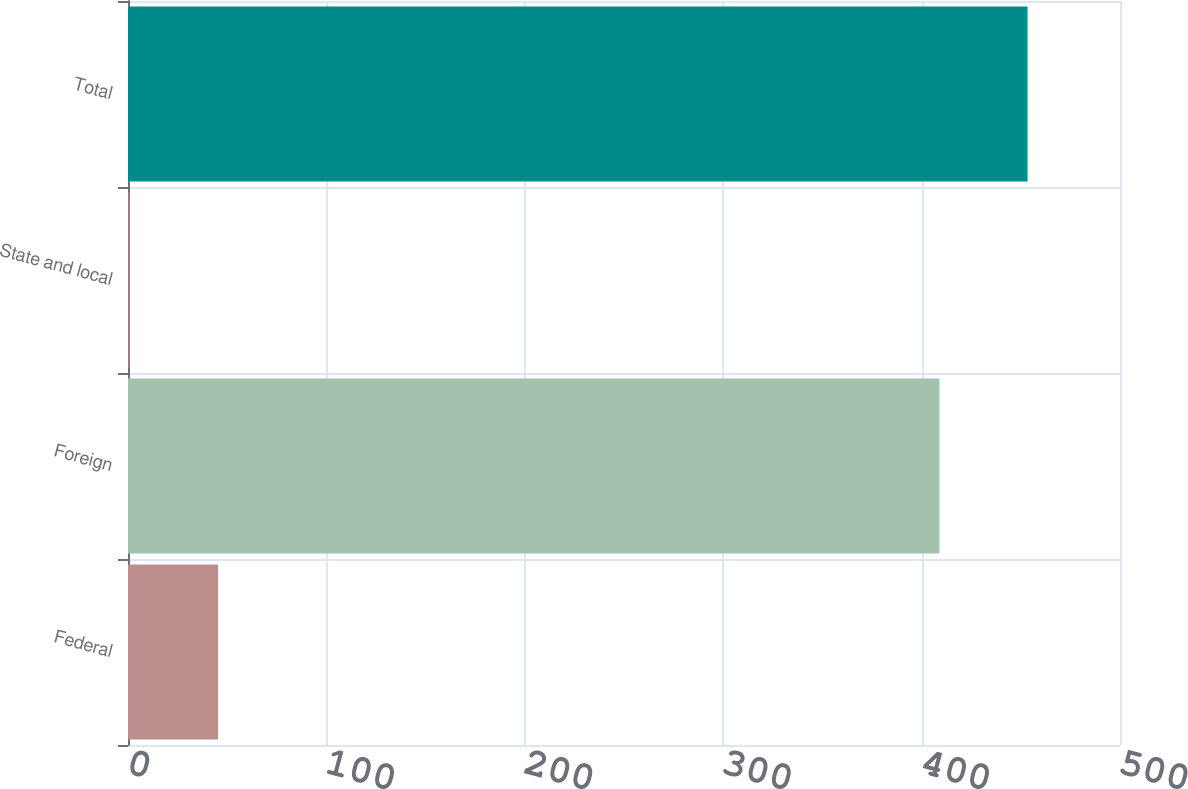<chart> <loc_0><loc_0><loc_500><loc_500><bar_chart><fcel>Federal<fcel>Foreign<fcel>State and local<fcel>Total<nl><fcel>45.4<fcel>409<fcel>1<fcel>453.4<nl></chart> 